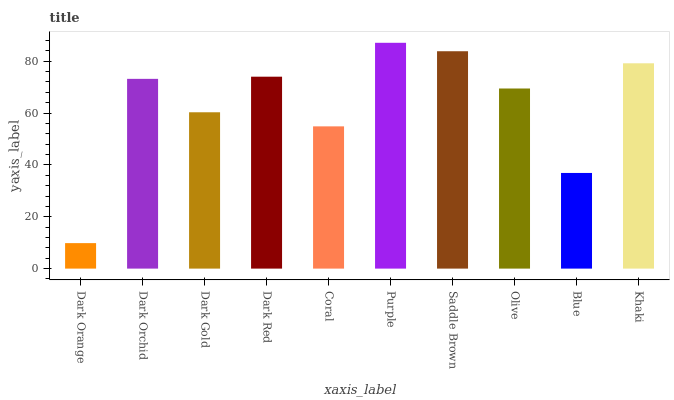Is Dark Orange the minimum?
Answer yes or no. Yes. Is Purple the maximum?
Answer yes or no. Yes. Is Dark Orchid the minimum?
Answer yes or no. No. Is Dark Orchid the maximum?
Answer yes or no. No. Is Dark Orchid greater than Dark Orange?
Answer yes or no. Yes. Is Dark Orange less than Dark Orchid?
Answer yes or no. Yes. Is Dark Orange greater than Dark Orchid?
Answer yes or no. No. Is Dark Orchid less than Dark Orange?
Answer yes or no. No. Is Dark Orchid the high median?
Answer yes or no. Yes. Is Olive the low median?
Answer yes or no. Yes. Is Dark Orange the high median?
Answer yes or no. No. Is Dark Orchid the low median?
Answer yes or no. No. 